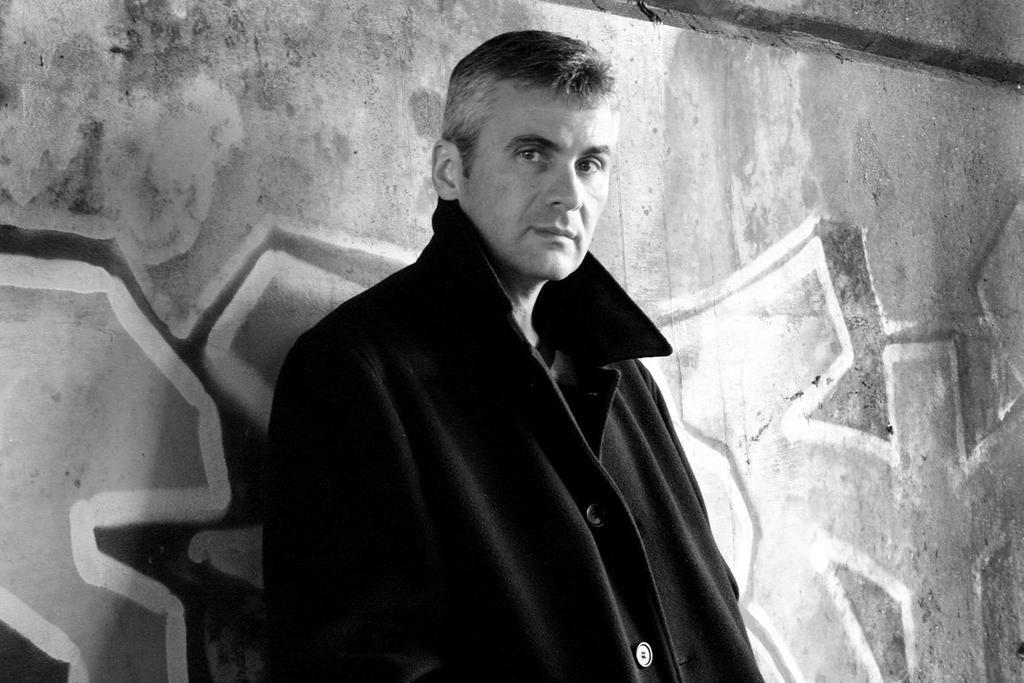Who or what is present in the image? There is a person in the image. What is the person wearing? The person is wearing a black jacket. Where is the person located in the image? The person is standing near a wall. What can be seen on the wall in the background of the image? There is graffiti on the wall in the background of the image. What type of pancake is being served on the wall in the image? There is no pancake present in the image; the wall features graffiti instead. Which berry is the person holding in the image? The person is not holding any berries in the image; they are wearing a black jacket and standing near a wall with graffiti. 